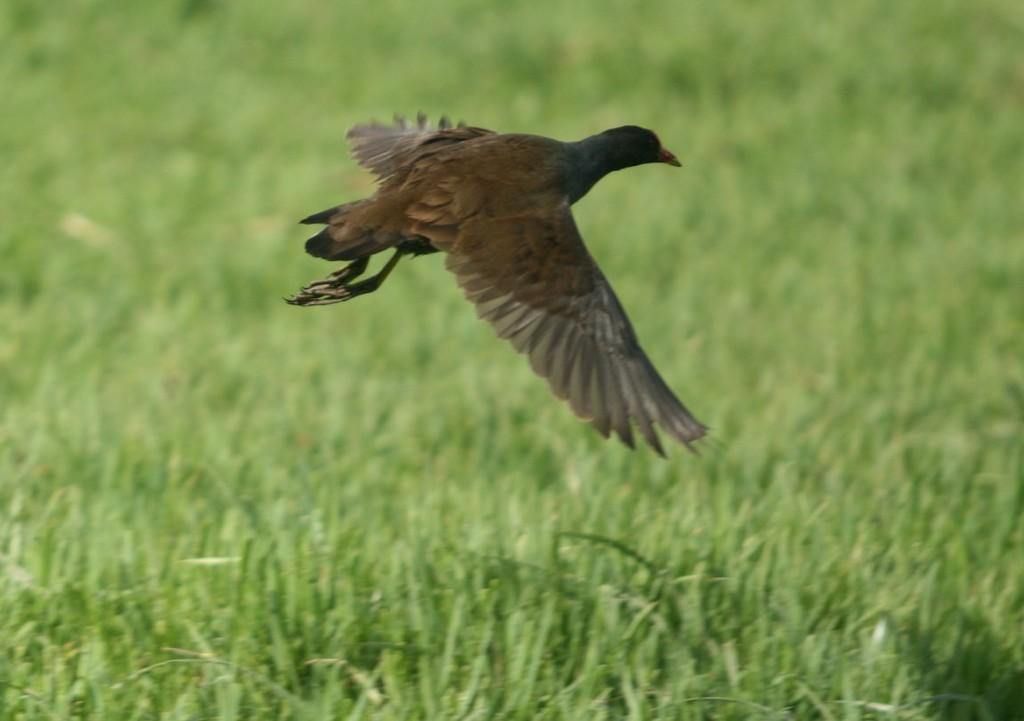What type of animal can be seen in the image? There is a bird in the image. What is the bird doing in the image? The bird is flying in the air. What can be seen in the background of the image? There is grass visible in the background of the image. What type of book is the bird holding in the image? There is no book present in the image; it features a bird flying in the air. 